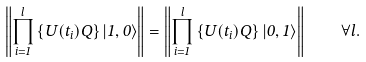<formula> <loc_0><loc_0><loc_500><loc_500>\left \| \prod _ { i = 1 } ^ { l } \left \{ U ( t _ { i } ) Q \right \} \left | 1 , 0 \right \rangle \right \| = \left \| \prod _ { i = 1 } ^ { l } \left \{ U ( t _ { i } ) Q \right \} \left | 0 , 1 \right \rangle \right \| \quad \forall l .</formula> 